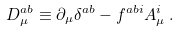Convert formula to latex. <formula><loc_0><loc_0><loc_500><loc_500>D _ { \mu } ^ { a b } \equiv \partial _ { \mu } \delta ^ { a b } - f ^ { a b i } A _ { \mu } ^ { i } \, .</formula> 